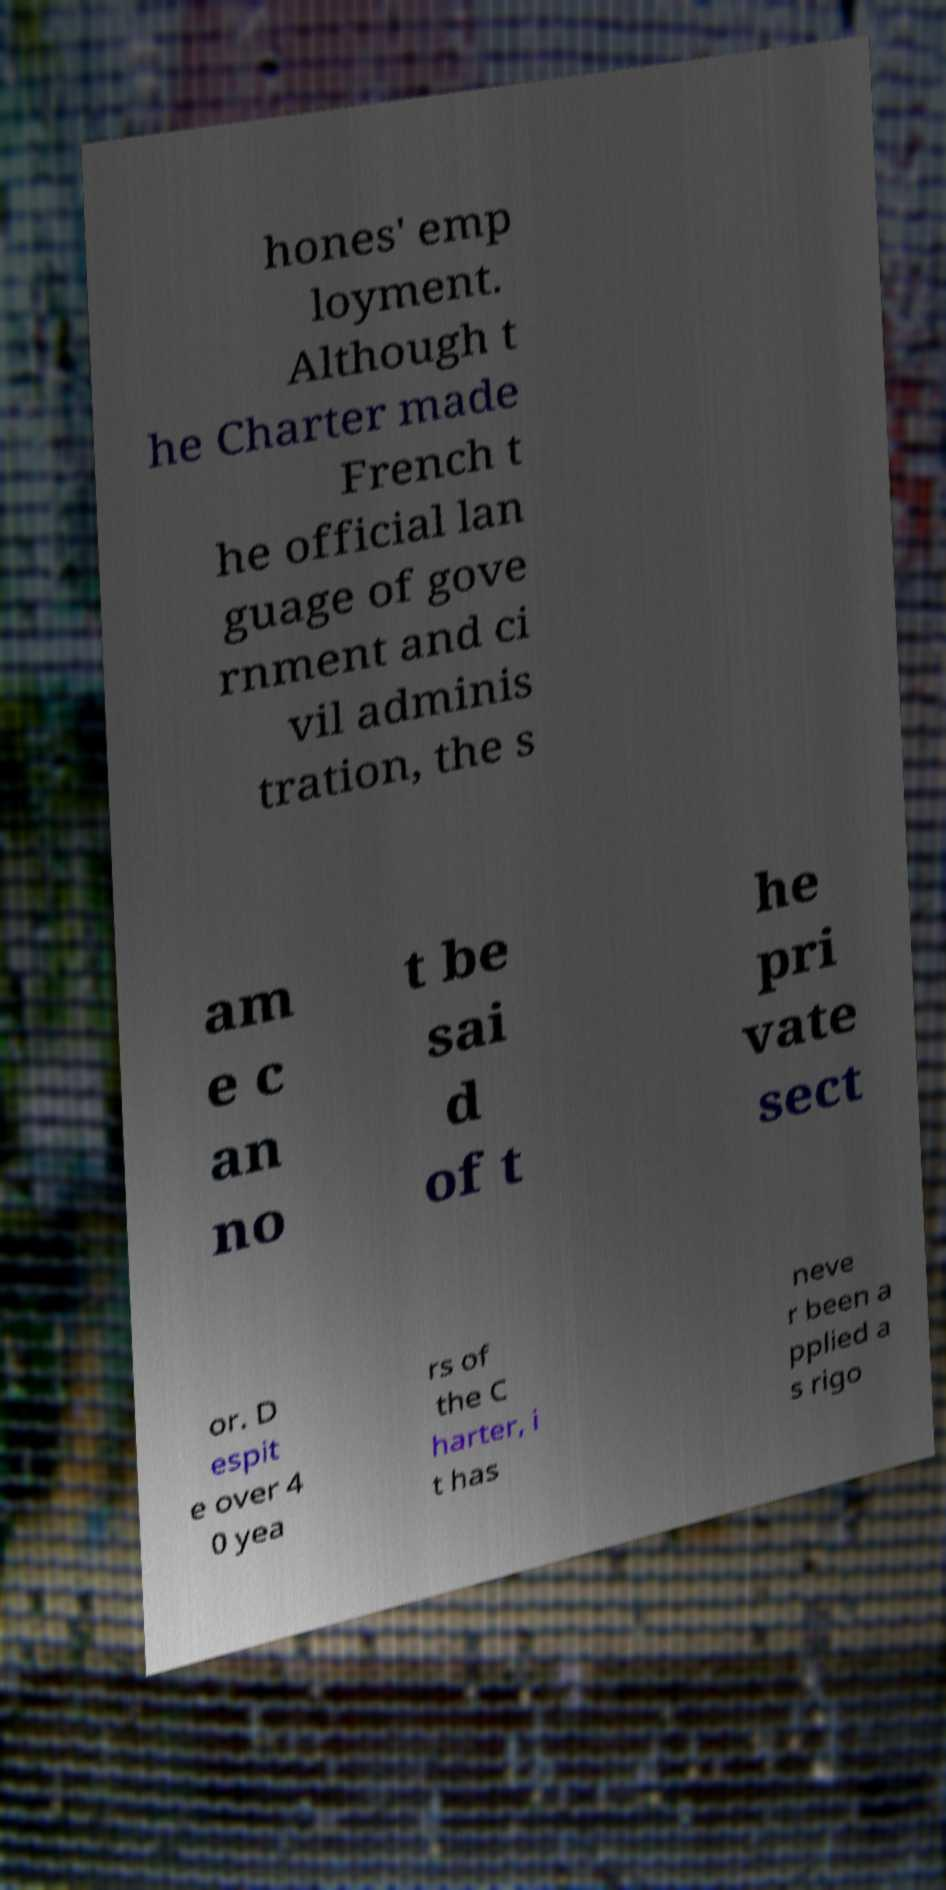Could you extract and type out the text from this image? hones' emp loyment. Although t he Charter made French t he official lan guage of gove rnment and ci vil adminis tration, the s am e c an no t be sai d of t he pri vate sect or. D espit e over 4 0 yea rs of the C harter, i t has neve r been a pplied a s rigo 